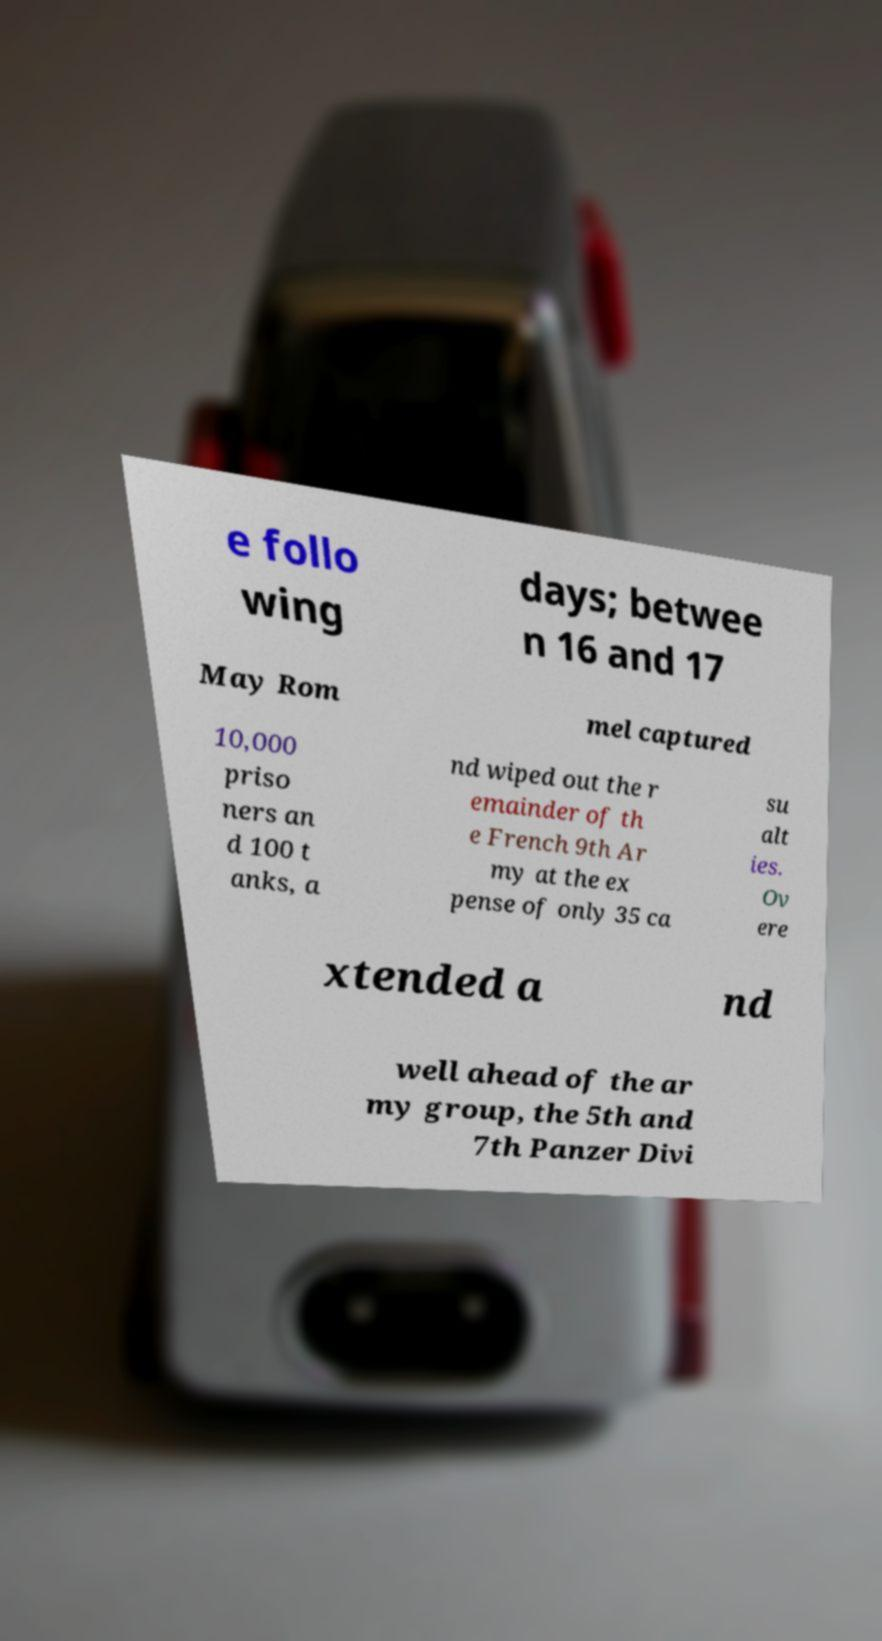Please identify and transcribe the text found in this image. e follo wing days; betwee n 16 and 17 May Rom mel captured 10,000 priso ners an d 100 t anks, a nd wiped out the r emainder of th e French 9th Ar my at the ex pense of only 35 ca su alt ies. Ov ere xtended a nd well ahead of the ar my group, the 5th and 7th Panzer Divi 